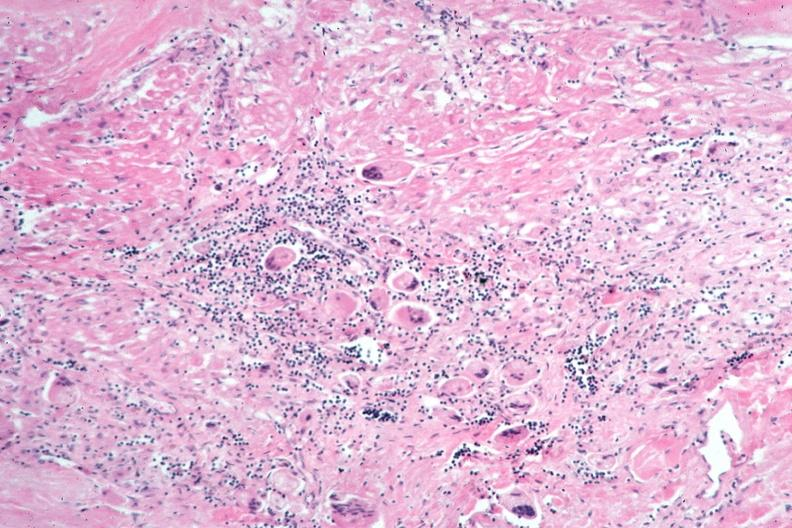s respiratory present?
Answer the question using a single word or phrase. Yes 